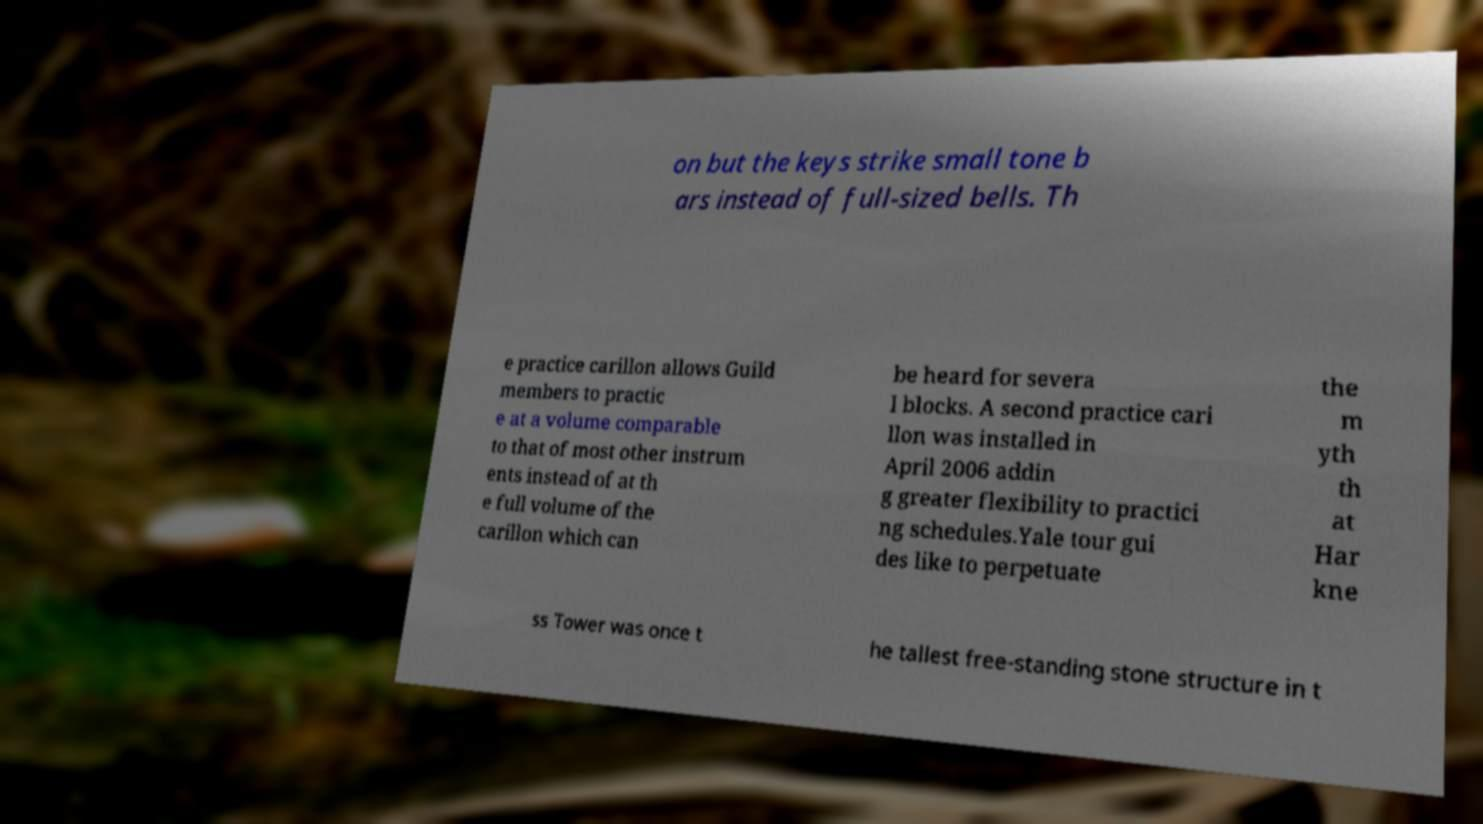Can you accurately transcribe the text from the provided image for me? on but the keys strike small tone b ars instead of full-sized bells. Th e practice carillon allows Guild members to practic e at a volume comparable to that of most other instrum ents instead of at th e full volume of the carillon which can be heard for severa l blocks. A second practice cari llon was installed in April 2006 addin g greater flexibility to practici ng schedules.Yale tour gui des like to perpetuate the m yth th at Har kne ss Tower was once t he tallest free-standing stone structure in t 